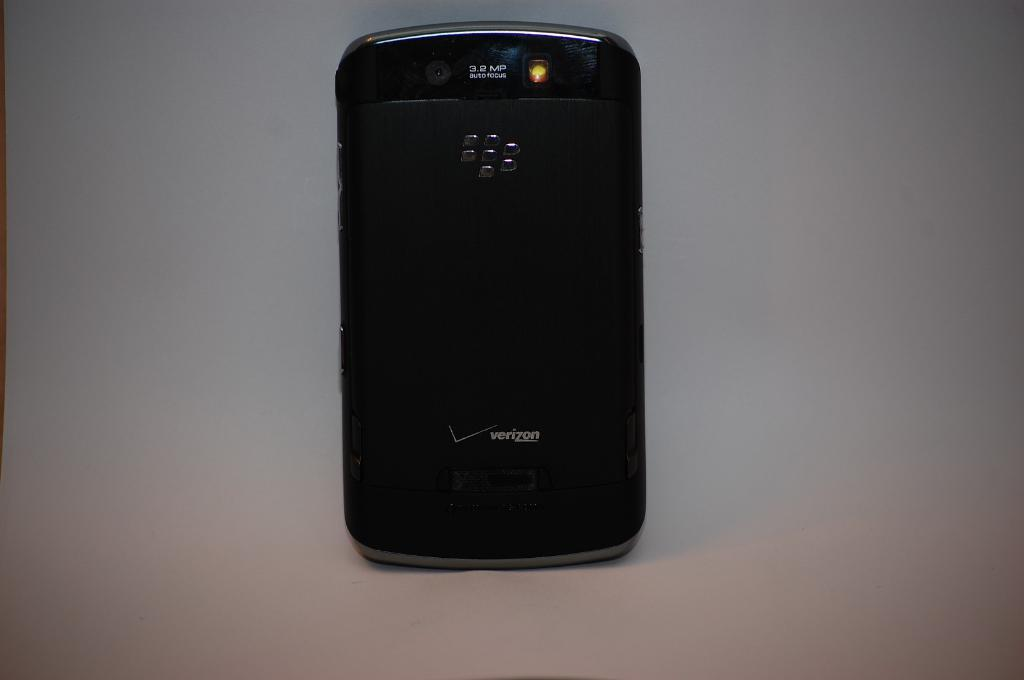<image>
Create a compact narrative representing the image presented. The back of a Verizon branded phone and a 3.2 megapixel camera at the top. 